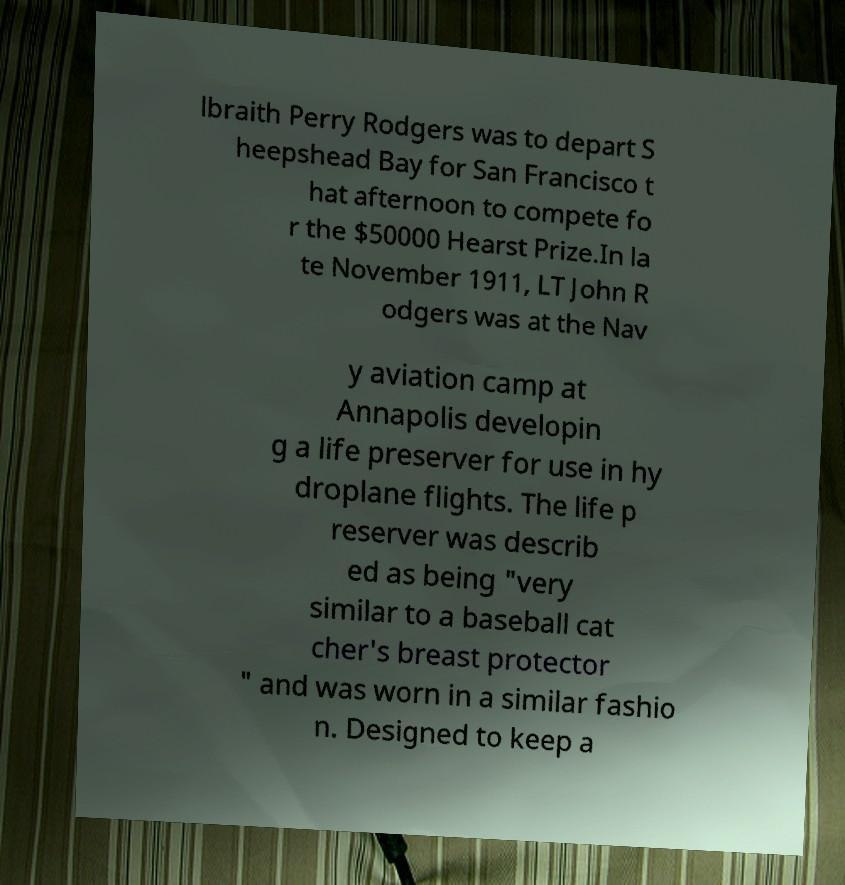Could you assist in decoding the text presented in this image and type it out clearly? lbraith Perry Rodgers was to depart S heepshead Bay for San Francisco t hat afternoon to compete fo r the $50000 Hearst Prize.In la te November 1911, LT John R odgers was at the Nav y aviation camp at Annapolis developin g a life preserver for use in hy droplane flights. The life p reserver was describ ed as being "very similar to a baseball cat cher's breast protector " and was worn in a similar fashio n. Designed to keep a 